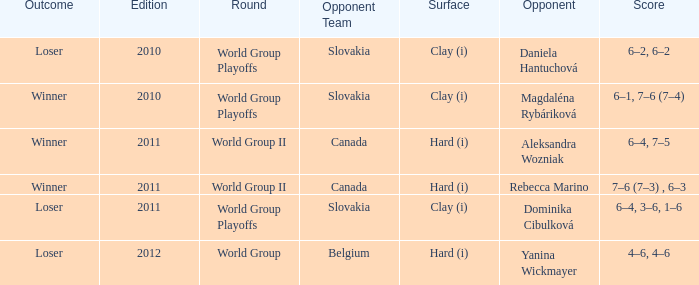What was the score when the opposing team was from Belgium? 4–6, 4–6. 